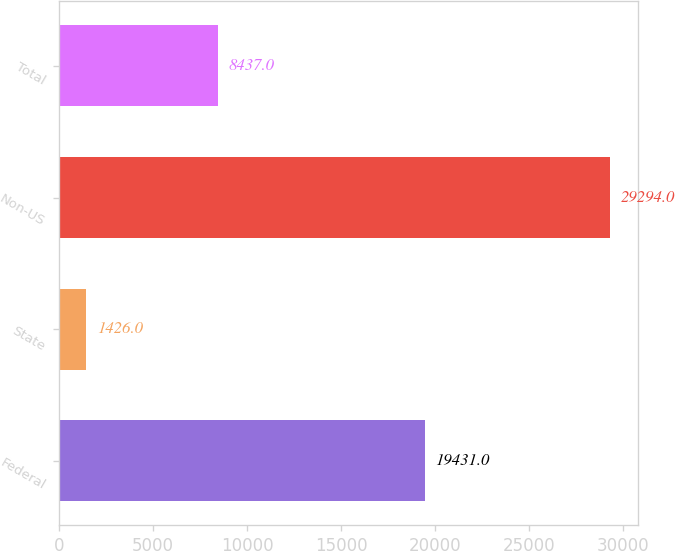Convert chart to OTSL. <chart><loc_0><loc_0><loc_500><loc_500><bar_chart><fcel>Federal<fcel>State<fcel>Non-US<fcel>Total<nl><fcel>19431<fcel>1426<fcel>29294<fcel>8437<nl></chart> 